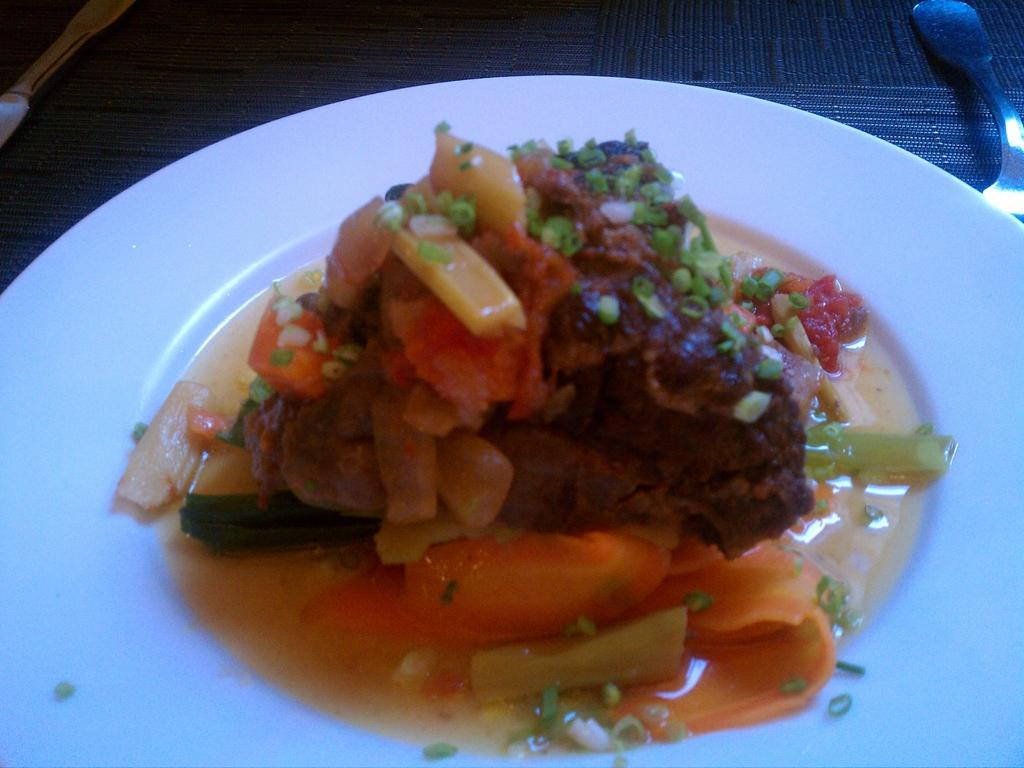What is on the table in the image? There is a plate and a fork on the table. What is on the plate? The plate contains sheds, meat, and other food items. What utensil is present on the table? There is a fork on the table. What type of juice is being served in the image? There is no juice present in the image; the plate contains sheds, meat, and other food items. Is there any blood visible on the plate in the image? There is no blood visible on the plate in the image; it contains sheds, meat, and other food items. 